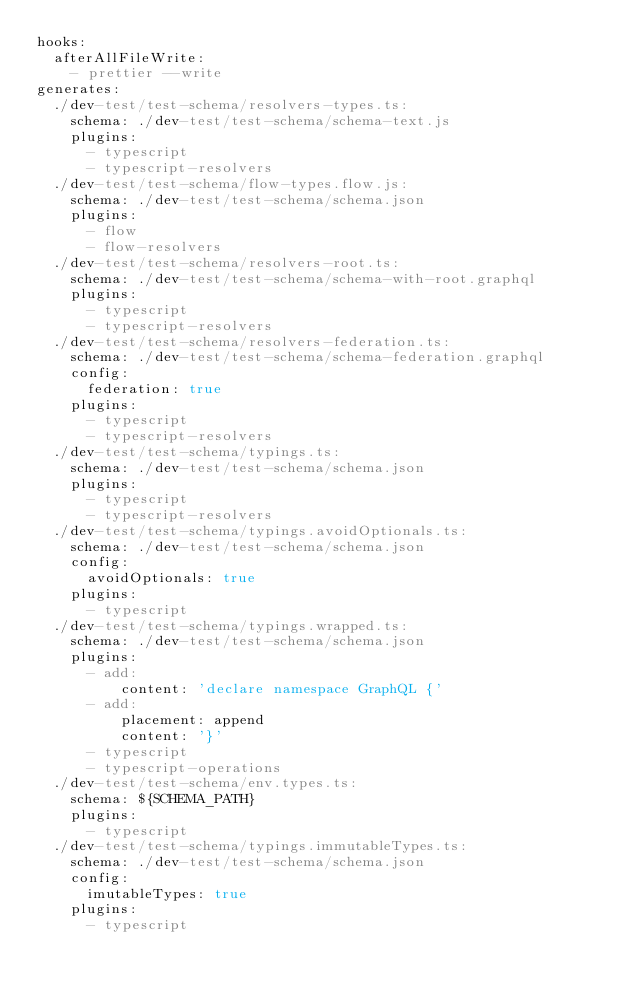<code> <loc_0><loc_0><loc_500><loc_500><_YAML_>hooks:
  afterAllFileWrite:
    - prettier --write
generates:
  ./dev-test/test-schema/resolvers-types.ts:
    schema: ./dev-test/test-schema/schema-text.js
    plugins:
      - typescript
      - typescript-resolvers
  ./dev-test/test-schema/flow-types.flow.js:
    schema: ./dev-test/test-schema/schema.json
    plugins:
      - flow
      - flow-resolvers
  ./dev-test/test-schema/resolvers-root.ts:
    schema: ./dev-test/test-schema/schema-with-root.graphql
    plugins:
      - typescript
      - typescript-resolvers
  ./dev-test/test-schema/resolvers-federation.ts:
    schema: ./dev-test/test-schema/schema-federation.graphql
    config:
      federation: true
    plugins:
      - typescript
      - typescript-resolvers
  ./dev-test/test-schema/typings.ts:
    schema: ./dev-test/test-schema/schema.json
    plugins:
      - typescript
      - typescript-resolvers
  ./dev-test/test-schema/typings.avoidOptionals.ts:
    schema: ./dev-test/test-schema/schema.json
    config:
      avoidOptionals: true
    plugins:
      - typescript
  ./dev-test/test-schema/typings.wrapped.ts:
    schema: ./dev-test/test-schema/schema.json
    plugins:
      - add:
          content: 'declare namespace GraphQL {'
      - add:
          placement: append
          content: '}'
      - typescript
      - typescript-operations
  ./dev-test/test-schema/env.types.ts:
    schema: ${SCHEMA_PATH}
    plugins:
      - typescript
  ./dev-test/test-schema/typings.immutableTypes.ts:
    schema: ./dev-test/test-schema/schema.json
    config:
      imutableTypes: true
    plugins:
      - typescript</code> 